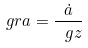Convert formula to latex. <formula><loc_0><loc_0><loc_500><loc_500>\ g r a = \frac { \dot { a } } { \ g z }</formula> 